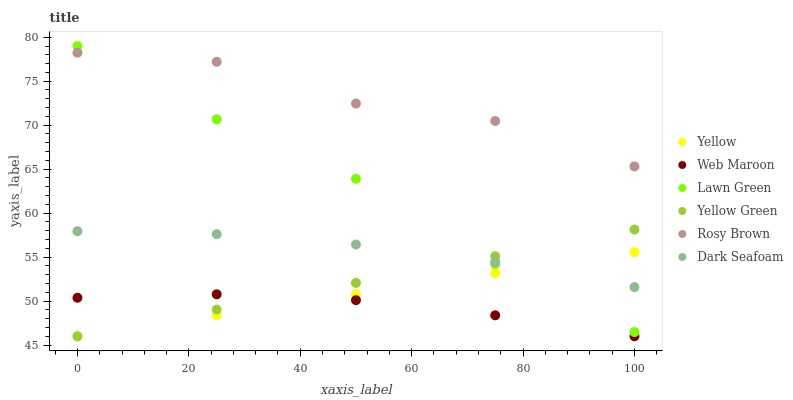Does Web Maroon have the minimum area under the curve?
Answer yes or no. Yes. Does Rosy Brown have the maximum area under the curve?
Answer yes or no. Yes. Does Yellow Green have the minimum area under the curve?
Answer yes or no. No. Does Yellow Green have the maximum area under the curve?
Answer yes or no. No. Is Yellow Green the smoothest?
Answer yes or no. Yes. Is Rosy Brown the roughest?
Answer yes or no. Yes. Is Rosy Brown the smoothest?
Answer yes or no. No. Is Yellow Green the roughest?
Answer yes or no. No. Does Yellow Green have the lowest value?
Answer yes or no. Yes. Does Rosy Brown have the lowest value?
Answer yes or no. No. Does Lawn Green have the highest value?
Answer yes or no. Yes. Does Yellow Green have the highest value?
Answer yes or no. No. Is Web Maroon less than Rosy Brown?
Answer yes or no. Yes. Is Rosy Brown greater than Yellow Green?
Answer yes or no. Yes. Does Yellow Green intersect Lawn Green?
Answer yes or no. Yes. Is Yellow Green less than Lawn Green?
Answer yes or no. No. Is Yellow Green greater than Lawn Green?
Answer yes or no. No. Does Web Maroon intersect Rosy Brown?
Answer yes or no. No. 